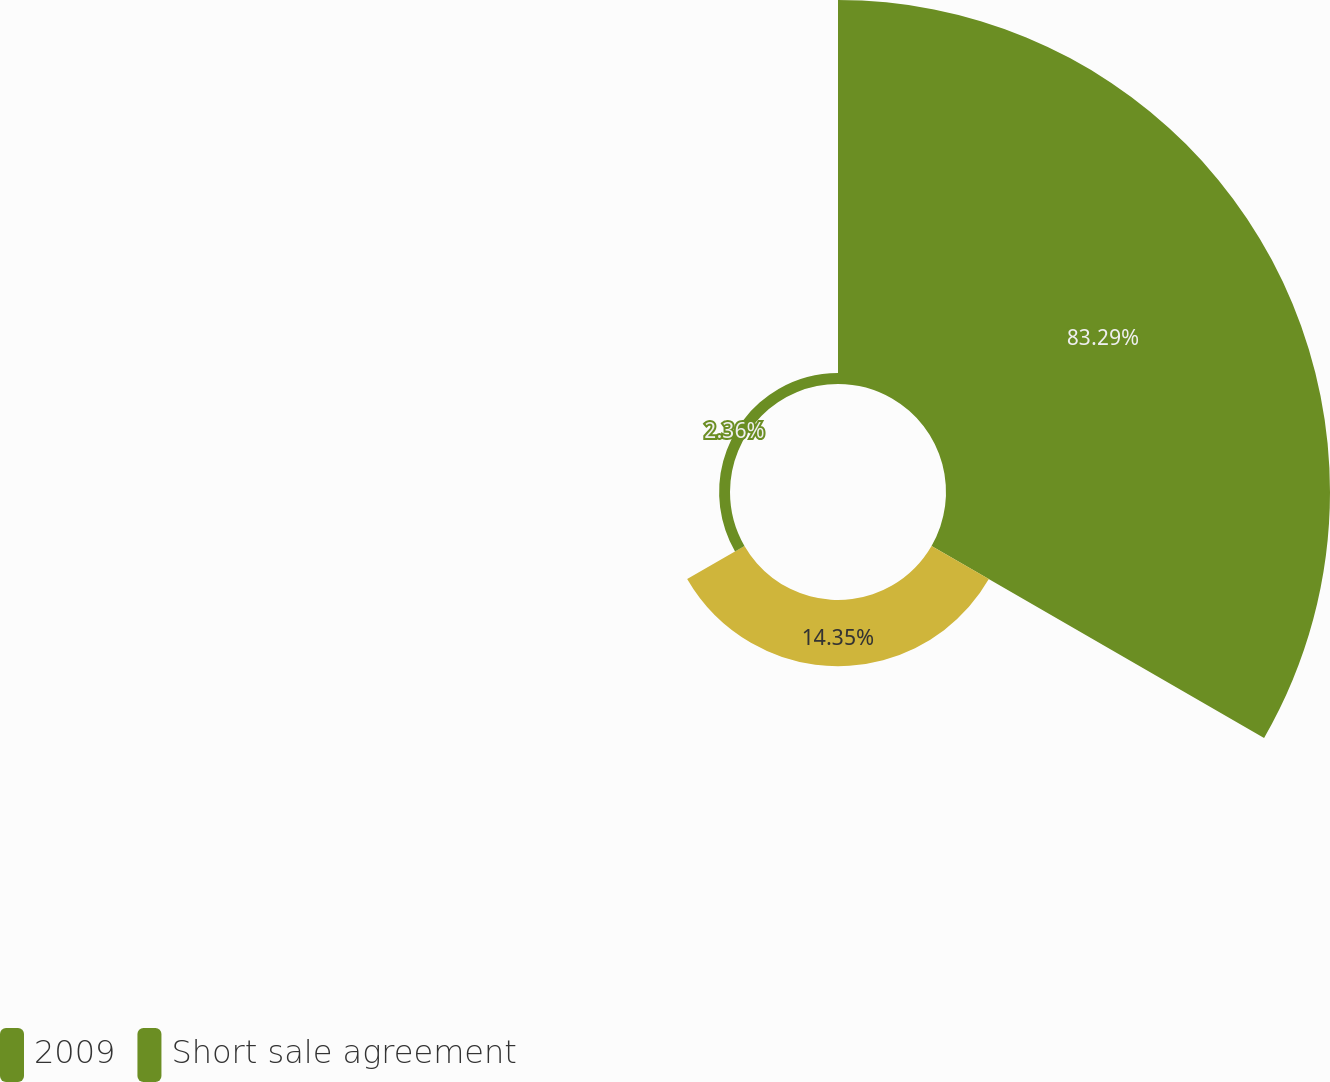Convert chart to OTSL. <chart><loc_0><loc_0><loc_500><loc_500><pie_chart><fcel>2009<fcel>Unnamed: 1<fcel>Short sale agreement<nl><fcel>83.28%<fcel>14.35%<fcel>2.36%<nl></chart> 